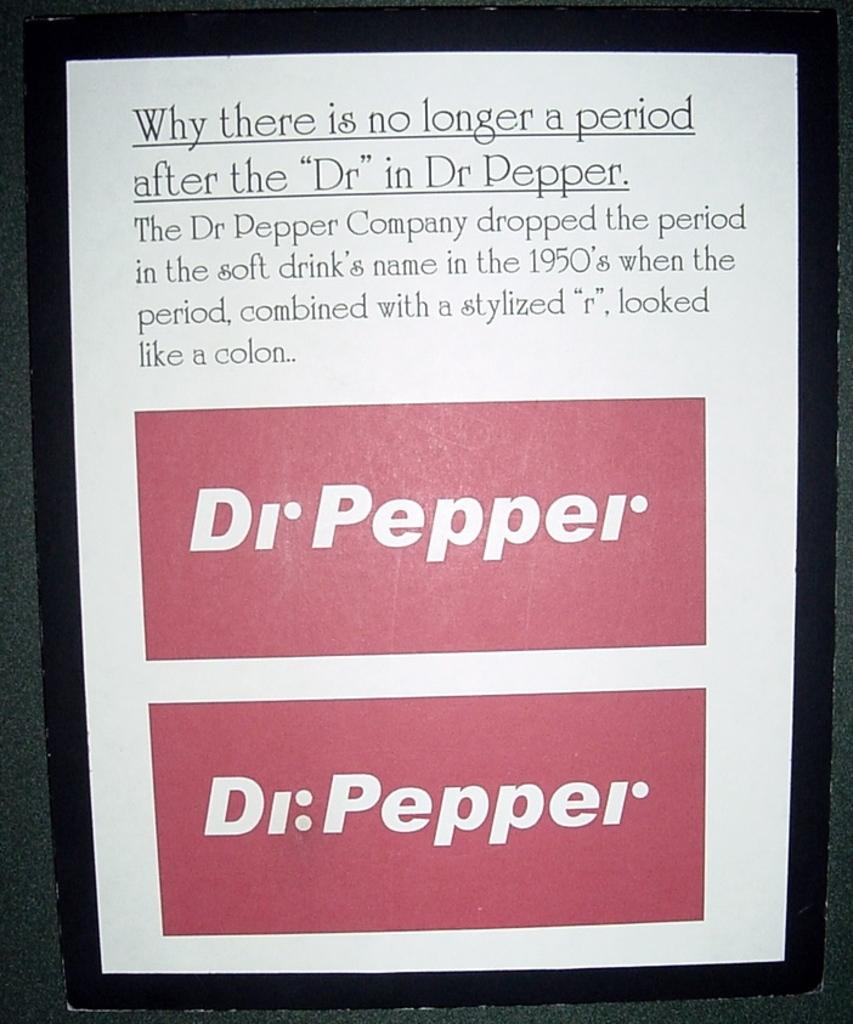<image>
Share a concise interpretation of the image provided. A framed sign explains Why there is no longer a period after the Dr in Dr Pepper. 